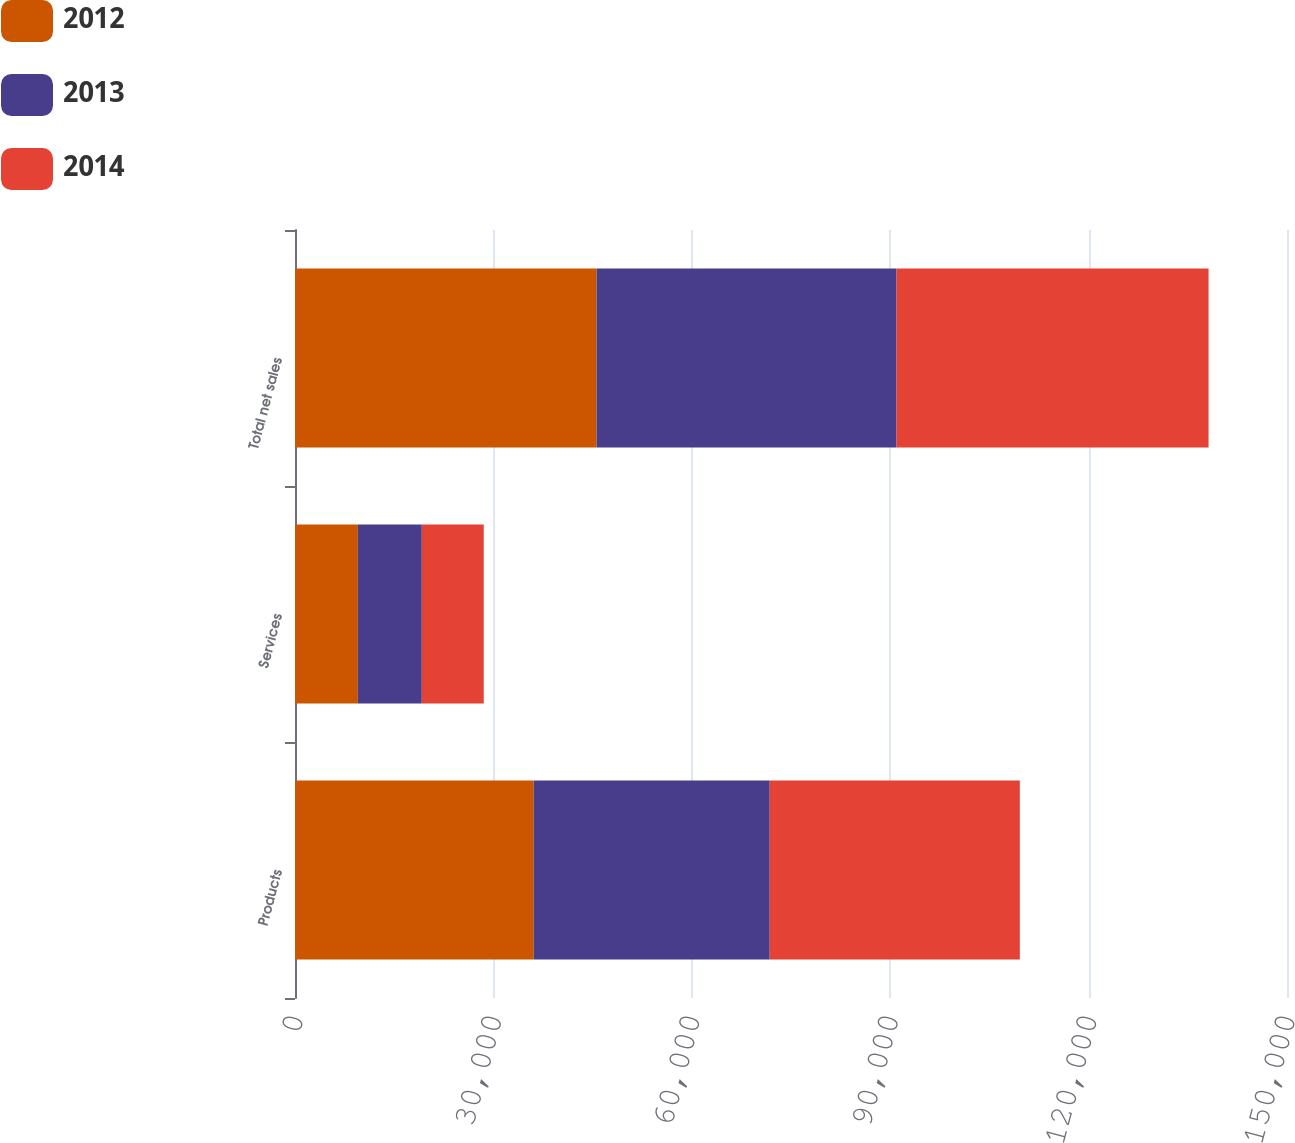Convert chart. <chart><loc_0><loc_0><loc_500><loc_500><stacked_bar_chart><ecel><fcel>Products<fcel>Services<fcel>Total net sales<nl><fcel>2012<fcel>36093<fcel>9507<fcel>45600<nl><fcel>2013<fcel>35691<fcel>9667<fcel>45358<nl><fcel>2014<fcel>37817<fcel>9365<fcel>47182<nl></chart> 